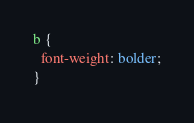Convert code to text. <code><loc_0><loc_0><loc_500><loc_500><_CSS_>b {
  font-weight: bolder;
}
</code> 